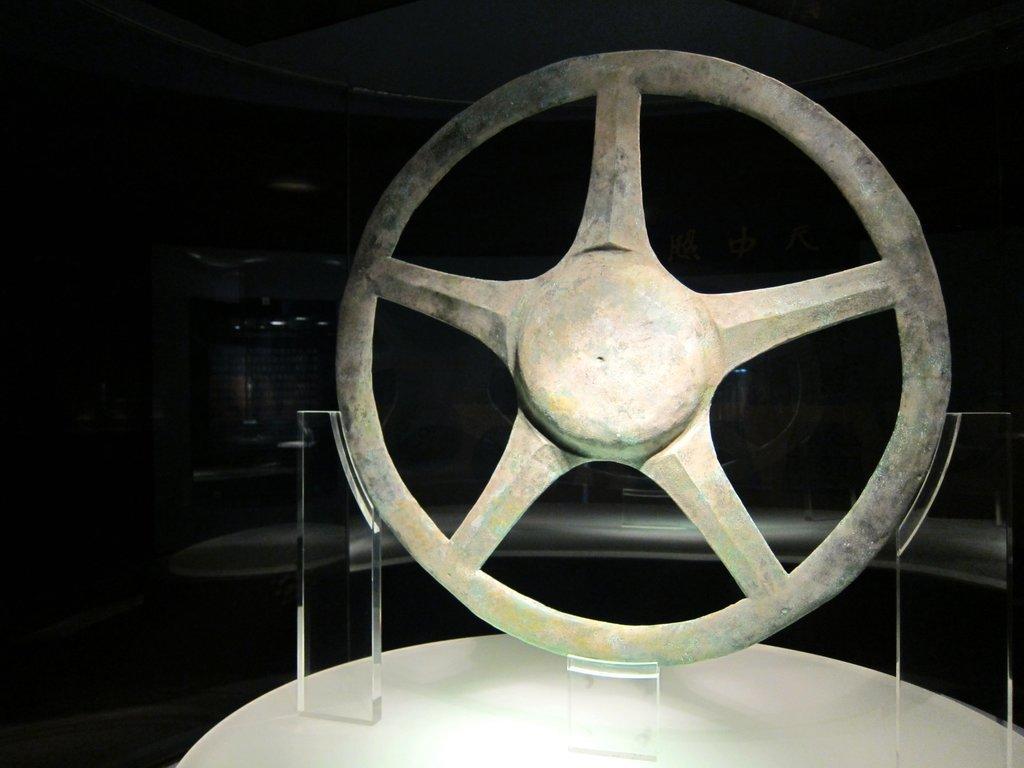Describe this image in one or two sentences. In this image I can see the steering on the glass stands. These are on the white color surface. 